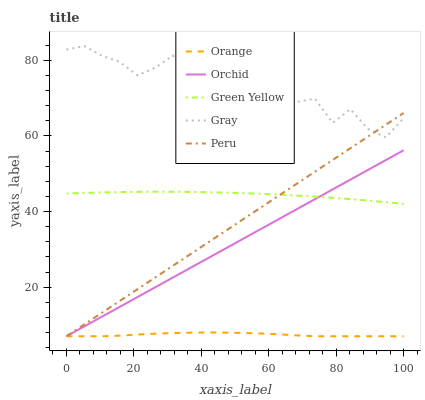Does Orange have the minimum area under the curve?
Answer yes or no. Yes. Does Gray have the maximum area under the curve?
Answer yes or no. Yes. Does Green Yellow have the minimum area under the curve?
Answer yes or no. No. Does Green Yellow have the maximum area under the curve?
Answer yes or no. No. Is Orchid the smoothest?
Answer yes or no. Yes. Is Gray the roughest?
Answer yes or no. Yes. Is Green Yellow the smoothest?
Answer yes or no. No. Is Green Yellow the roughest?
Answer yes or no. No. Does Orange have the lowest value?
Answer yes or no. Yes. Does Green Yellow have the lowest value?
Answer yes or no. No. Does Gray have the highest value?
Answer yes or no. Yes. Does Green Yellow have the highest value?
Answer yes or no. No. Is Orange less than Gray?
Answer yes or no. Yes. Is Gray greater than Orchid?
Answer yes or no. Yes. Does Gray intersect Peru?
Answer yes or no. Yes. Is Gray less than Peru?
Answer yes or no. No. Is Gray greater than Peru?
Answer yes or no. No. Does Orange intersect Gray?
Answer yes or no. No. 